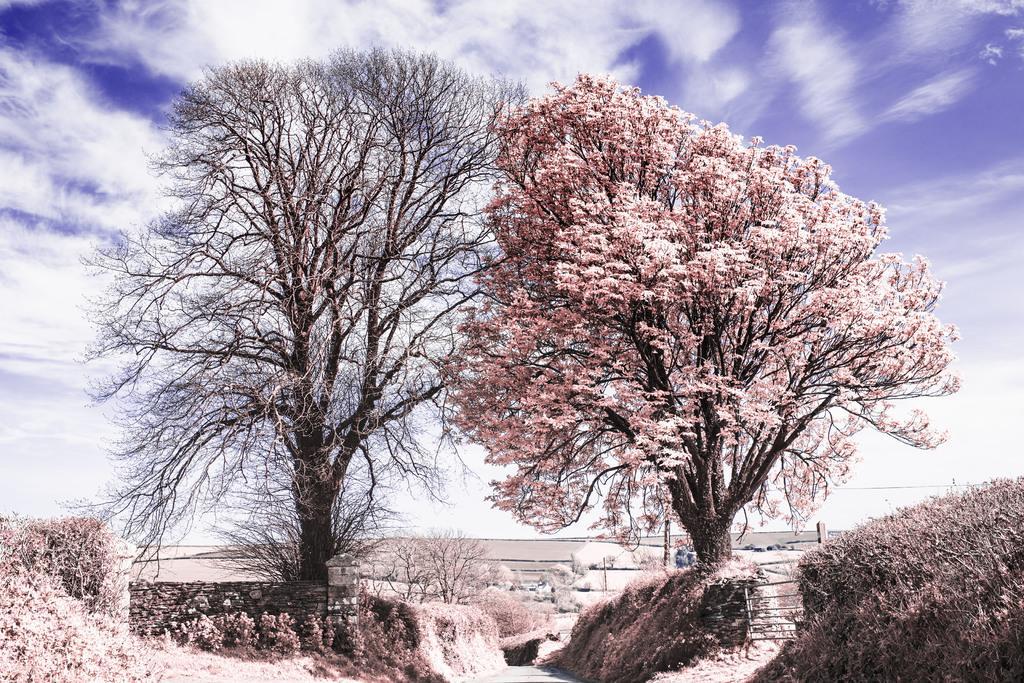Can you describe this image briefly? In this picture there are trees in the center of the image, it seems to be there is a boundary in the background area of the image. 